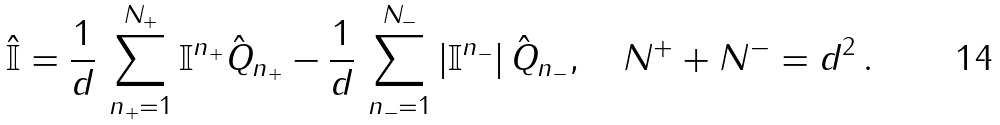<formula> <loc_0><loc_0><loc_500><loc_500>\hat { \mathbb { I } } = \frac { 1 } { d } \, \sum _ { n _ { + } = 1 } ^ { N _ { + } } \mathbb { I } ^ { n _ { + } } \hat { Q } _ { n _ { + } } - \frac { 1 } { d } \, \sum _ { n _ { - } = 1 } ^ { N _ { - } } \left | \mathbb { I } ^ { n _ { - } } \right | \hat { Q } _ { n _ { - } } , \quad N ^ { + } + N ^ { - } = d ^ { 2 } \, .</formula> 